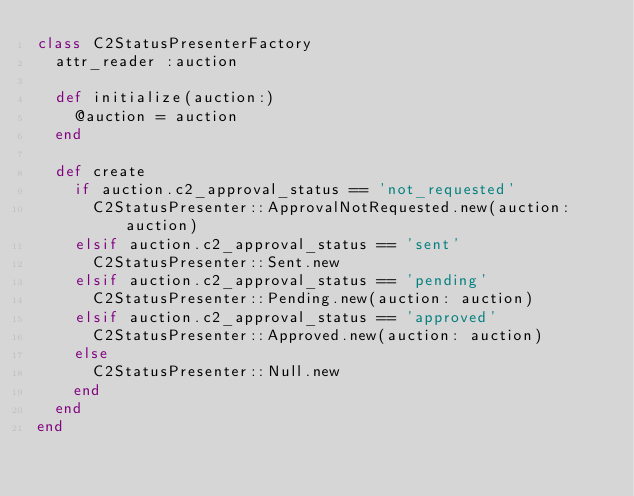Convert code to text. <code><loc_0><loc_0><loc_500><loc_500><_Ruby_>class C2StatusPresenterFactory
  attr_reader :auction

  def initialize(auction:)
    @auction = auction
  end

  def create
    if auction.c2_approval_status == 'not_requested'
      C2StatusPresenter::ApprovalNotRequested.new(auction: auction)
    elsif auction.c2_approval_status == 'sent'
      C2StatusPresenter::Sent.new
    elsif auction.c2_approval_status == 'pending'
      C2StatusPresenter::Pending.new(auction: auction)
    elsif auction.c2_approval_status == 'approved'
      C2StatusPresenter::Approved.new(auction: auction)
    else
      C2StatusPresenter::Null.new
    end
  end
end
</code> 